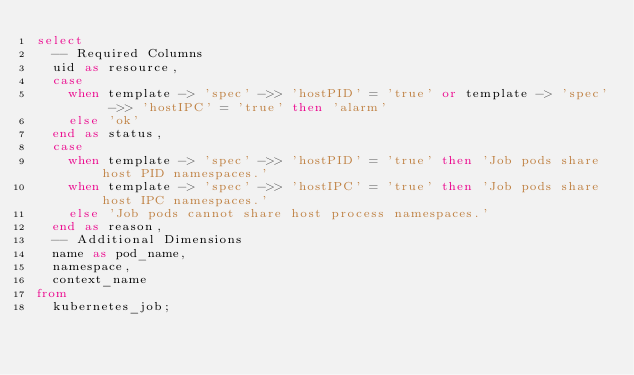Convert code to text. <code><loc_0><loc_0><loc_500><loc_500><_SQL_>select
  -- Required Columns
  uid as resource,
  case
    when template -> 'spec' ->> 'hostPID' = 'true' or template -> 'spec' ->> 'hostIPC' = 'true' then 'alarm'
    else 'ok'
  end as status,
  case
    when template -> 'spec' ->> 'hostPID' = 'true' then 'Job pods share host PID namespaces.'
    when template -> 'spec' ->> 'hostIPC' = 'true' then 'Job pods share host IPC namespaces.'
    else 'Job pods cannot share host process namespaces.'
  end as reason,
  -- Additional Dimensions
  name as pod_name,
  namespace,
  context_name
from
  kubernetes_job;</code> 